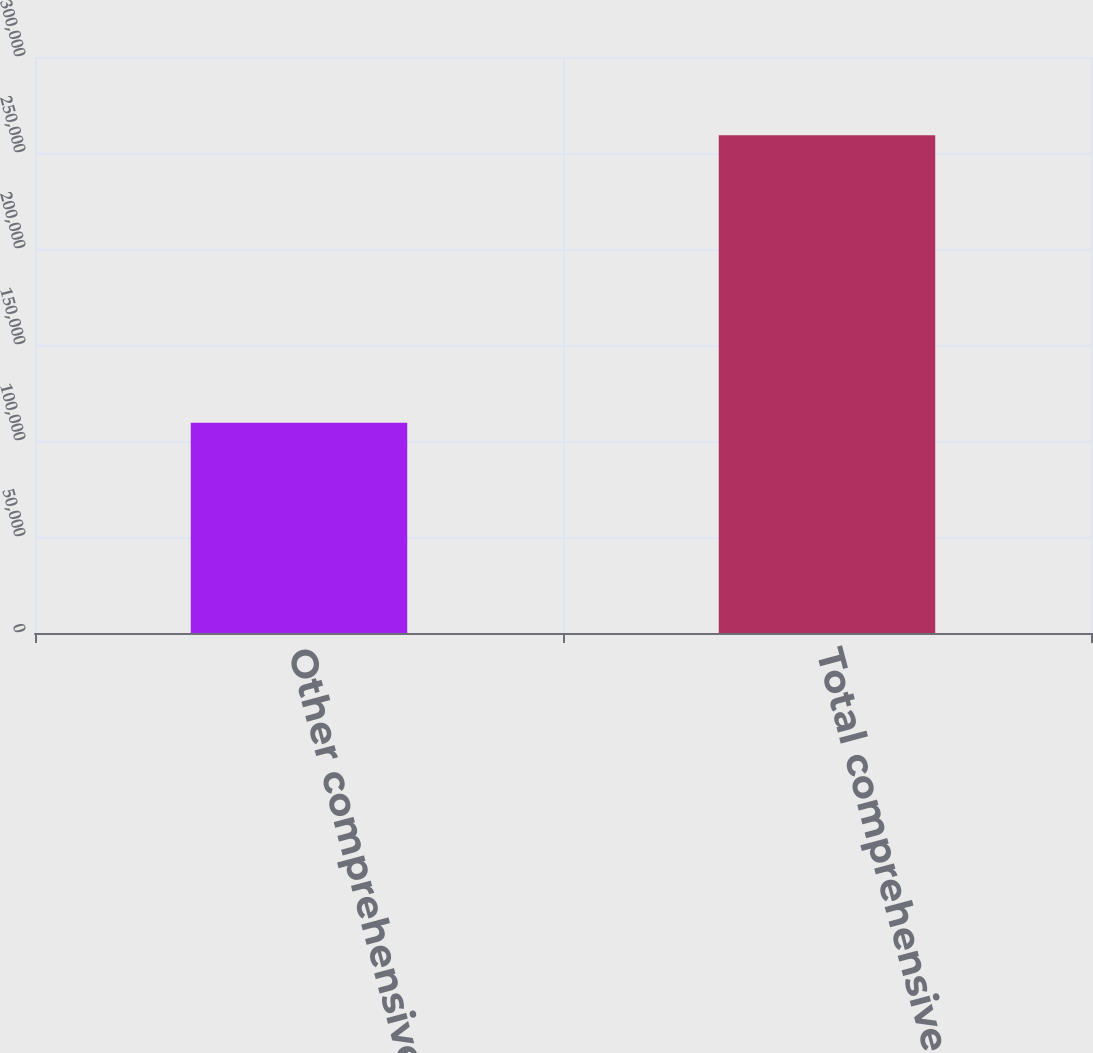<chart> <loc_0><loc_0><loc_500><loc_500><bar_chart><fcel>Other comprehensive loss<fcel>Total comprehensive income<nl><fcel>109507<fcel>259200<nl></chart> 